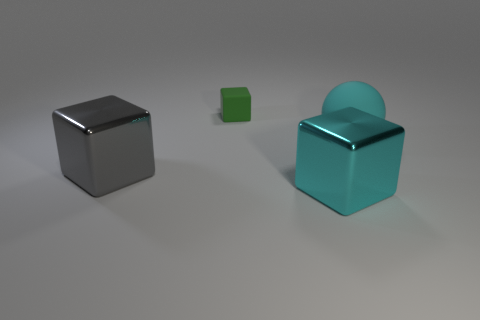What size is the metal object that is the same color as the large matte sphere?
Offer a very short reply. Large. There is a shiny object to the right of the gray cube; is its color the same as the big rubber ball?
Your answer should be compact. Yes. Are there more large gray cubes than small purple matte cylinders?
Offer a very short reply. Yes. There is a rubber object that is to the left of the cyan cube; is its shape the same as the gray shiny thing?
Make the answer very short. Yes. Are there fewer small brown matte spheres than metallic things?
Your answer should be compact. Yes. There is a gray block that is the same size as the cyan sphere; what is its material?
Offer a terse response. Metal. Does the large sphere have the same color as the large metallic cube that is to the right of the tiny block?
Provide a succinct answer. Yes. Are there fewer cubes that are in front of the large gray thing than cyan objects?
Offer a terse response. Yes. How many large yellow spheres are there?
Ensure brevity in your answer.  0. What shape is the small thing behind the large metallic object behind the large cyan metallic cube?
Your answer should be compact. Cube. 